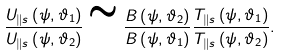Convert formula to latex. <formula><loc_0><loc_0><loc_500><loc_500>\frac { U _ { \| s } \left ( \psi , \vartheta _ { 1 } \right ) } { U _ { \| s } \left ( \psi , \vartheta _ { 2 } \right ) } \cong \frac { B \left ( \psi , \vartheta _ { 2 } \right ) } { B \left ( \psi , \vartheta _ { 1 } \right ) } \frac { T _ { \| s } \left ( \psi , \vartheta _ { 1 } \right ) } { T _ { \| s } \left ( \psi , \vartheta _ { 2 } \right ) } .</formula> 